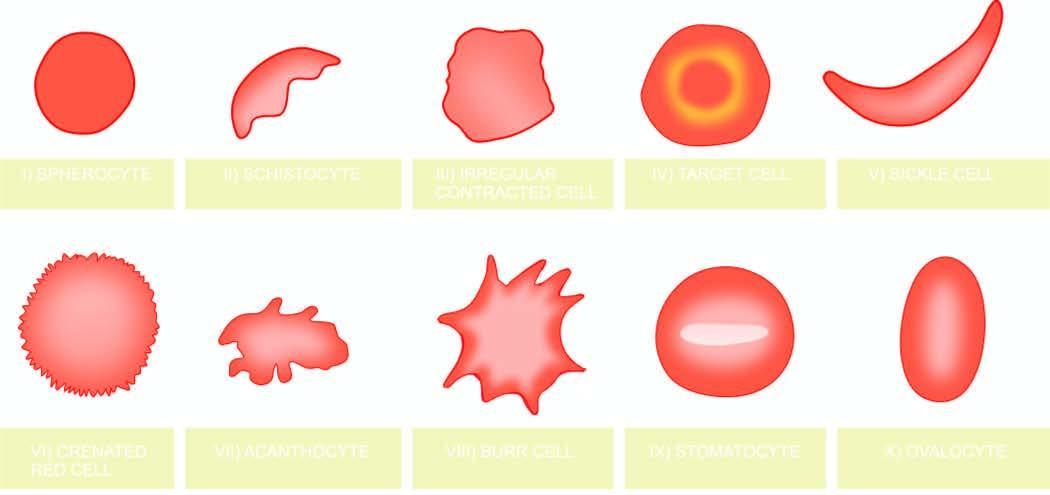what correspond to the order in which they are described in the text?
Answer the question using a single word or phrase. The serial numbers in the illustrations 